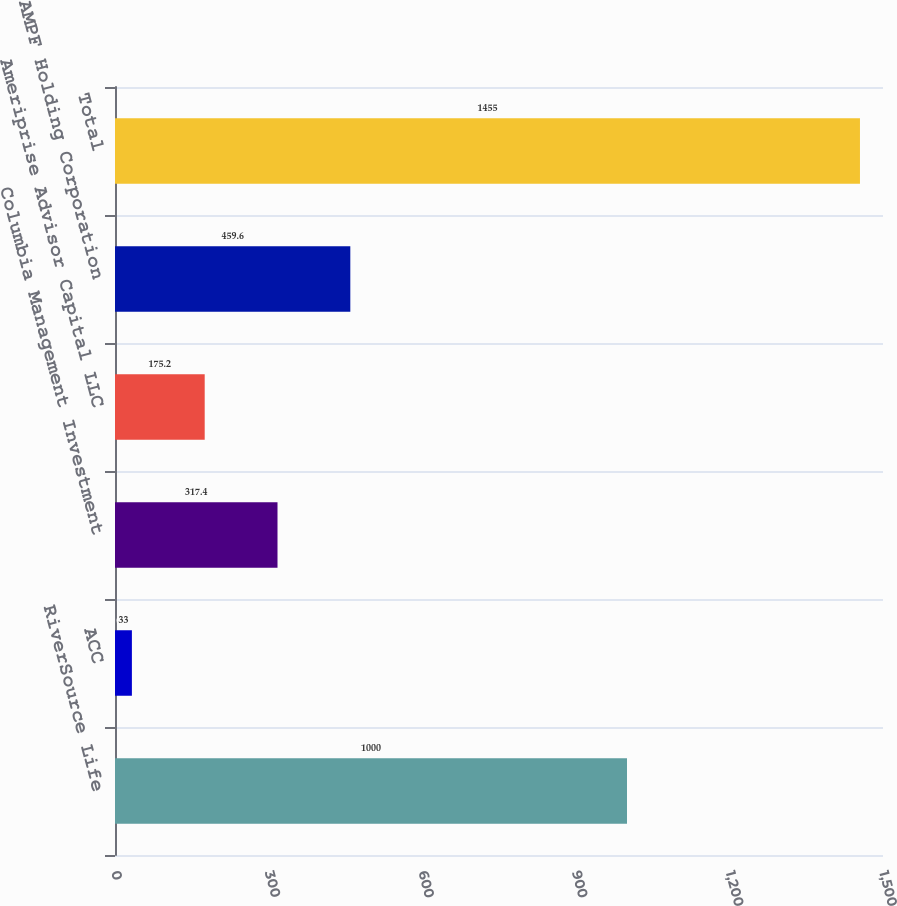Convert chart. <chart><loc_0><loc_0><loc_500><loc_500><bar_chart><fcel>RiverSource Life<fcel>ACC<fcel>Columbia Management Investment<fcel>Ameriprise Advisor Capital LLC<fcel>AMPF Holding Corporation<fcel>Total<nl><fcel>1000<fcel>33<fcel>317.4<fcel>175.2<fcel>459.6<fcel>1455<nl></chart> 